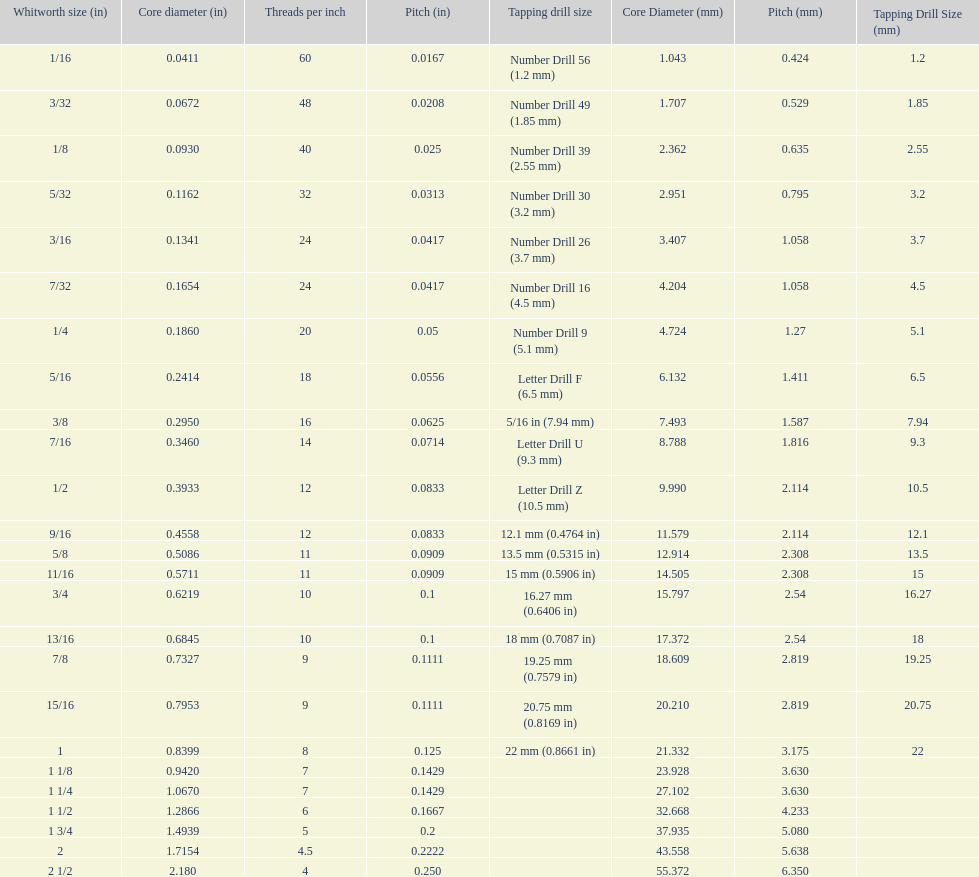What is the core diameter of the first 1/8 whitworth size (in)? 0.0930. 